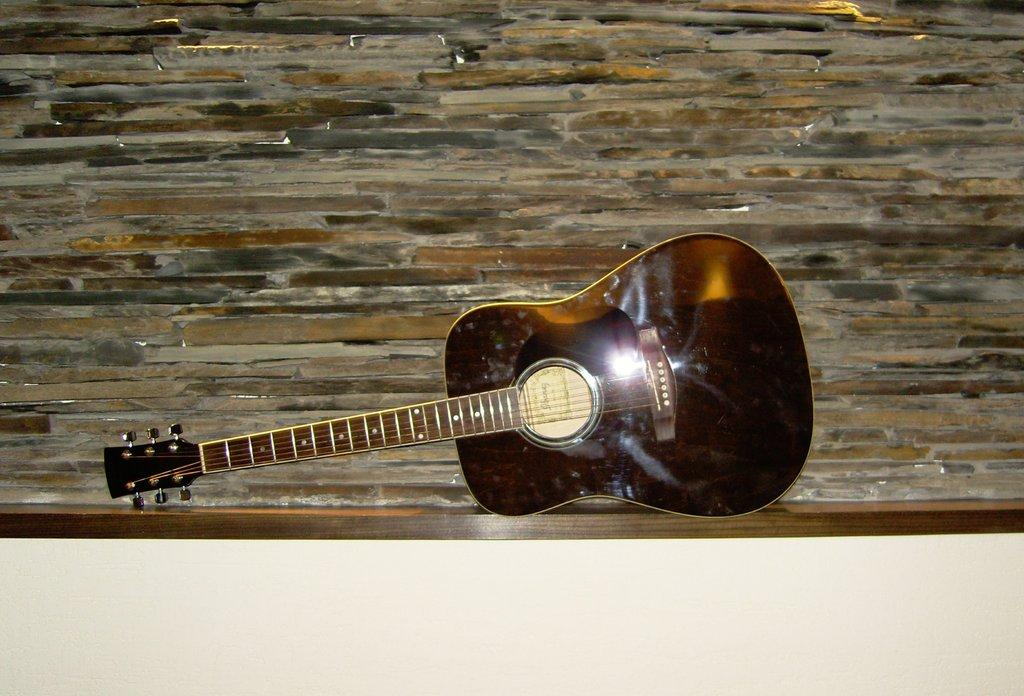What musical instrument is present in the image? There is a guitar in the image. How is the guitar positioned in the image? The guitar is placed on a wooden rack. What can be seen in the background of the image? There is a wall in the background of the image. What type of match is being played in the image? There is no match or any sporting activity present in the image; it features a guitar on a wooden rack. What type of dress is the guitar wearing in the image? The guitar is an inanimate object and does not wear clothing, such as a dress. 